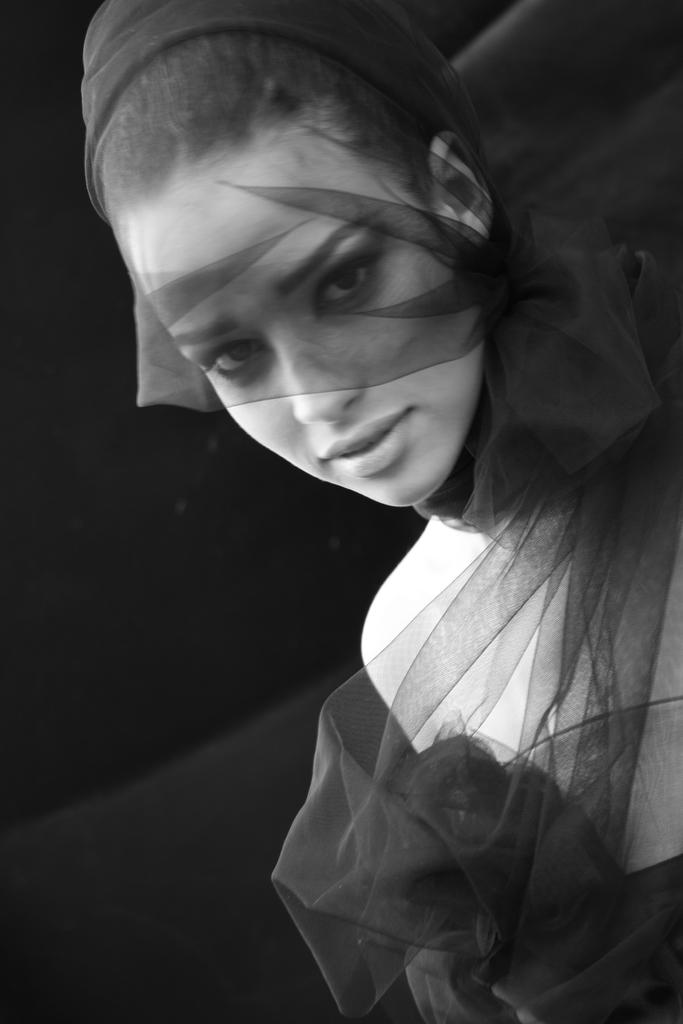What is the color scheme of the image? The image is black and white. Can you describe the main subject in the image? There is a lady in the image. What type of plastic material is the lady holding in the image? There is no plastic material visible in the image. What punishment is the lady receiving in the image? There is no punishment being depicted in the image. What nerve is the lady stimulating in the image? There is no nerve stimulation being depicted in the image. 